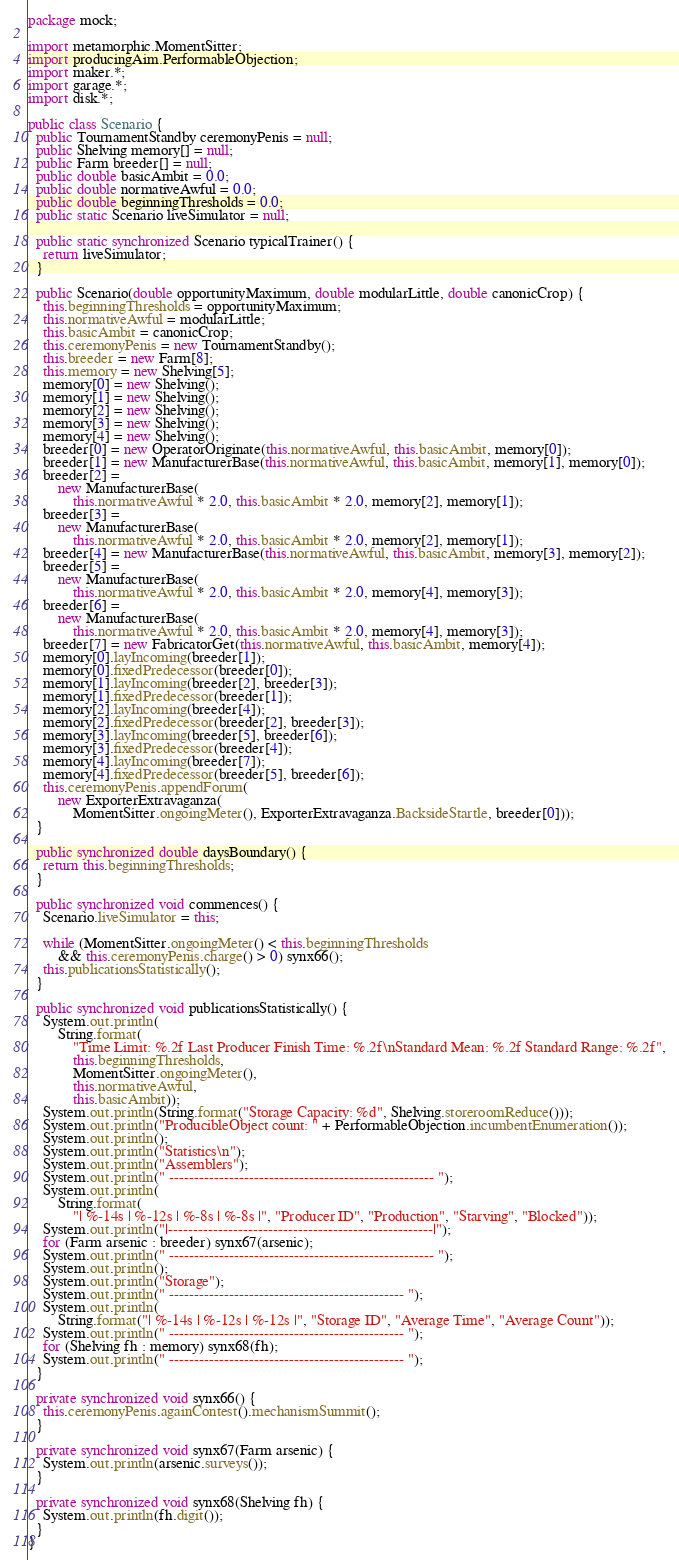<code> <loc_0><loc_0><loc_500><loc_500><_Java_>package mock;

import metamorphic.MomentSitter;
import producingAim.PerformableObjection;
import maker.*;
import garage.*;
import disk.*;

public class Scenario {
  public TournamentStandby ceremonyPenis = null;
  public Shelving memory[] = null;
  public Farm breeder[] = null;
  public double basicAmbit = 0.0;
  public double normativeAwful = 0.0;
  public double beginningThresholds = 0.0;
  public static Scenario liveSimulator = null;

  public static synchronized Scenario typicalTrainer() {
    return liveSimulator;
  }

  public Scenario(double opportunityMaximum, double modularLittle, double canonicCrop) {
    this.beginningThresholds = opportunityMaximum;
    this.normativeAwful = modularLittle;
    this.basicAmbit = canonicCrop;
    this.ceremonyPenis = new TournamentStandby();
    this.breeder = new Farm[8];
    this.memory = new Shelving[5];
    memory[0] = new Shelving();
    memory[1] = new Shelving();
    memory[2] = new Shelving();
    memory[3] = new Shelving();
    memory[4] = new Shelving();
    breeder[0] = new OperatorOriginate(this.normativeAwful, this.basicAmbit, memory[0]);
    breeder[1] = new ManufacturerBase(this.normativeAwful, this.basicAmbit, memory[1], memory[0]);
    breeder[2] =
        new ManufacturerBase(
            this.normativeAwful * 2.0, this.basicAmbit * 2.0, memory[2], memory[1]);
    breeder[3] =
        new ManufacturerBase(
            this.normativeAwful * 2.0, this.basicAmbit * 2.0, memory[2], memory[1]);
    breeder[4] = new ManufacturerBase(this.normativeAwful, this.basicAmbit, memory[3], memory[2]);
    breeder[5] =
        new ManufacturerBase(
            this.normativeAwful * 2.0, this.basicAmbit * 2.0, memory[4], memory[3]);
    breeder[6] =
        new ManufacturerBase(
            this.normativeAwful * 2.0, this.basicAmbit * 2.0, memory[4], memory[3]);
    breeder[7] = new FabricatorGet(this.normativeAwful, this.basicAmbit, memory[4]);
    memory[0].layIncoming(breeder[1]);
    memory[0].fixedPredecessor(breeder[0]);
    memory[1].layIncoming(breeder[2], breeder[3]);
    memory[1].fixedPredecessor(breeder[1]);
    memory[2].layIncoming(breeder[4]);
    memory[2].fixedPredecessor(breeder[2], breeder[3]);
    memory[3].layIncoming(breeder[5], breeder[6]);
    memory[3].fixedPredecessor(breeder[4]);
    memory[4].layIncoming(breeder[7]);
    memory[4].fixedPredecessor(breeder[5], breeder[6]);
    this.ceremonyPenis.appendForum(
        new ExporterExtravaganza(
            MomentSitter.ongoingMeter(), ExporterExtravaganza.BacksideStartle, breeder[0]));
  }

  public synchronized double daysBoundary() {
    return this.beginningThresholds;
  }

  public synchronized void commences() {
    Scenario.liveSimulator = this;

    while (MomentSitter.ongoingMeter() < this.beginningThresholds
        && this.ceremonyPenis.charge() > 0) synx66();
    this.publicationsStatistically();
  }

  public synchronized void publicationsStatistically() {
    System.out.println(
        String.format(
            "Time Limit: %.2f Last Producer Finish Time: %.2f\nStandard Mean: %.2f Standard Range: %.2f",
            this.beginningThresholds,
            MomentSitter.ongoingMeter(),
            this.normativeAwful,
            this.basicAmbit));
    System.out.println(String.format("Storage Capacity: %d", Shelving.storeroomReduce()));
    System.out.println("ProducibleObject count: " + PerformableObjection.incumbentEnumeration());
    System.out.println();
    System.out.println("Statistics\n");
    System.out.println("Assemblers");
    System.out.println(" ----------------------------------------------------- ");
    System.out.println(
        String.format(
            "| %-14s | %-12s | %-8s | %-8s |", "Producer ID", "Production", "Starving", "Blocked"));
    System.out.println("|-----------------------------------------------------|");
    for (Farm arsenic : breeder) synx67(arsenic);
    System.out.println(" ----------------------------------------------------- ");
    System.out.println();
    System.out.println("Storage");
    System.out.println(" ----------------------------------------------- ");
    System.out.println(
        String.format("| %-14s | %-12s | %-12s |", "Storage ID", "Average Time", "Average Count"));
    System.out.println(" ----------------------------------------------- ");
    for (Shelving fh : memory) synx68(fh);
    System.out.println(" ----------------------------------------------- ");
  }

  private synchronized void synx66() {
    this.ceremonyPenis.againContest().mechanismSummit();
  }

  private synchronized void synx67(Farm arsenic) {
    System.out.println(arsenic.surveys());
  }

  private synchronized void synx68(Shelving fh) {
    System.out.println(fh.digit());
  }
}
</code> 